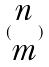Convert formula to latex. <formula><loc_0><loc_0><loc_500><loc_500>( \begin{matrix} n \\ m \end{matrix} )</formula> 